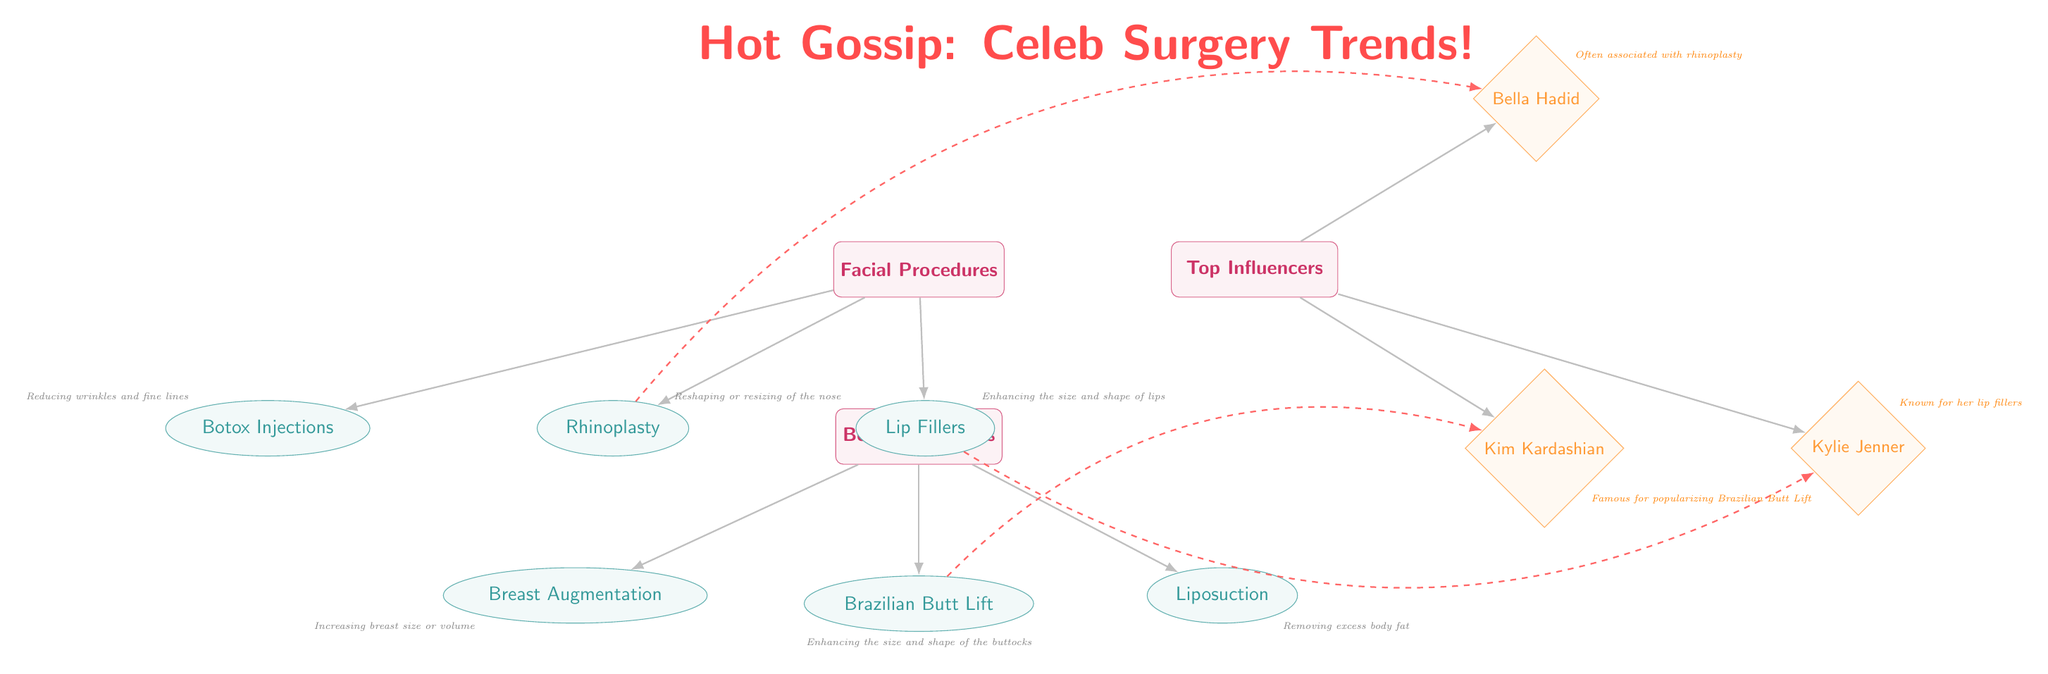What are the three categories of procedures shown in the diagram? The diagram features three categories: Facial Procedures, Body Procedures, and Top Influencers. These categories are visually represented as nodes, with each labeled distinctly at the top levels of the diagram.
Answer: Facial Procedures, Body Procedures, Top Influencers Which procedure is associated with Kim Kardashian? According to the diagram, Kim Kardashian is famous for popularizing the Brazilian Butt Lift, which is noted in the influencer's node connected to the body procedure node for BBL.
Answer: Brazilian Butt Lift How many facial procedures are listed in the diagram? The diagram lists three facial procedures: Rhinoplasty, Botox Injections, and Lip Fillers. These are indicated as the connected nodes directly under the Facial Procedures category.
Answer: 3 Which influencer is associated with lip fillers? The diagram connects Kylie Jenner's node to the Lip Fillers procedure, indicating her association with this specific body enhancement. This connection is represented as a dashed line labeled 'influenced by.'
Answer: Kylie Jenner What is the primary purpose of Rhinoplasty as described in the diagram? The diagram states that Rhinoplasty is for reshaping or resizing the nose. This purpose is labeled in small text next to the Rhinoplasty node, providing essential information about the procedure.
Answer: Reshaping or resizing of the nose Which body procedure has the least number of connections to influencers? Liposuction has no direct connections to any influencers in the diagram, making it the body procedure with the least connections to the influencer category. The other two body procedures, Breast Augmentation and Brazilian Butt Lift, have one each connected to influencers.
Answer: Liposuction What does the edge type 'contains' signify in this diagram? The 'contains' edge type indicates that the listed procedures are part of their respective categories, such as 'Facial Procedures' and 'Body Procedures.' This is visually indicated by solid lines connecting the categories to the procedure nodes.
Answer: Procedures categorized How many total influencer nodes are represented in the diagram? There are three influencer nodes shown in the diagram: Kim Kardashian, Kylie Jenner, and Bella Hadid. Each influencer is represented as a diamond-shaped node connected to the top influencers category.
Answer: 3 Which procedure is indicated as enhancing the size and shape of lips? The Lip Fillers procedure is specifically identified in the diagram as enhancing the size and shape of lips, which is noted in the description text adjacent to the Lip Fillers node.
Answer: Lip Fillers 